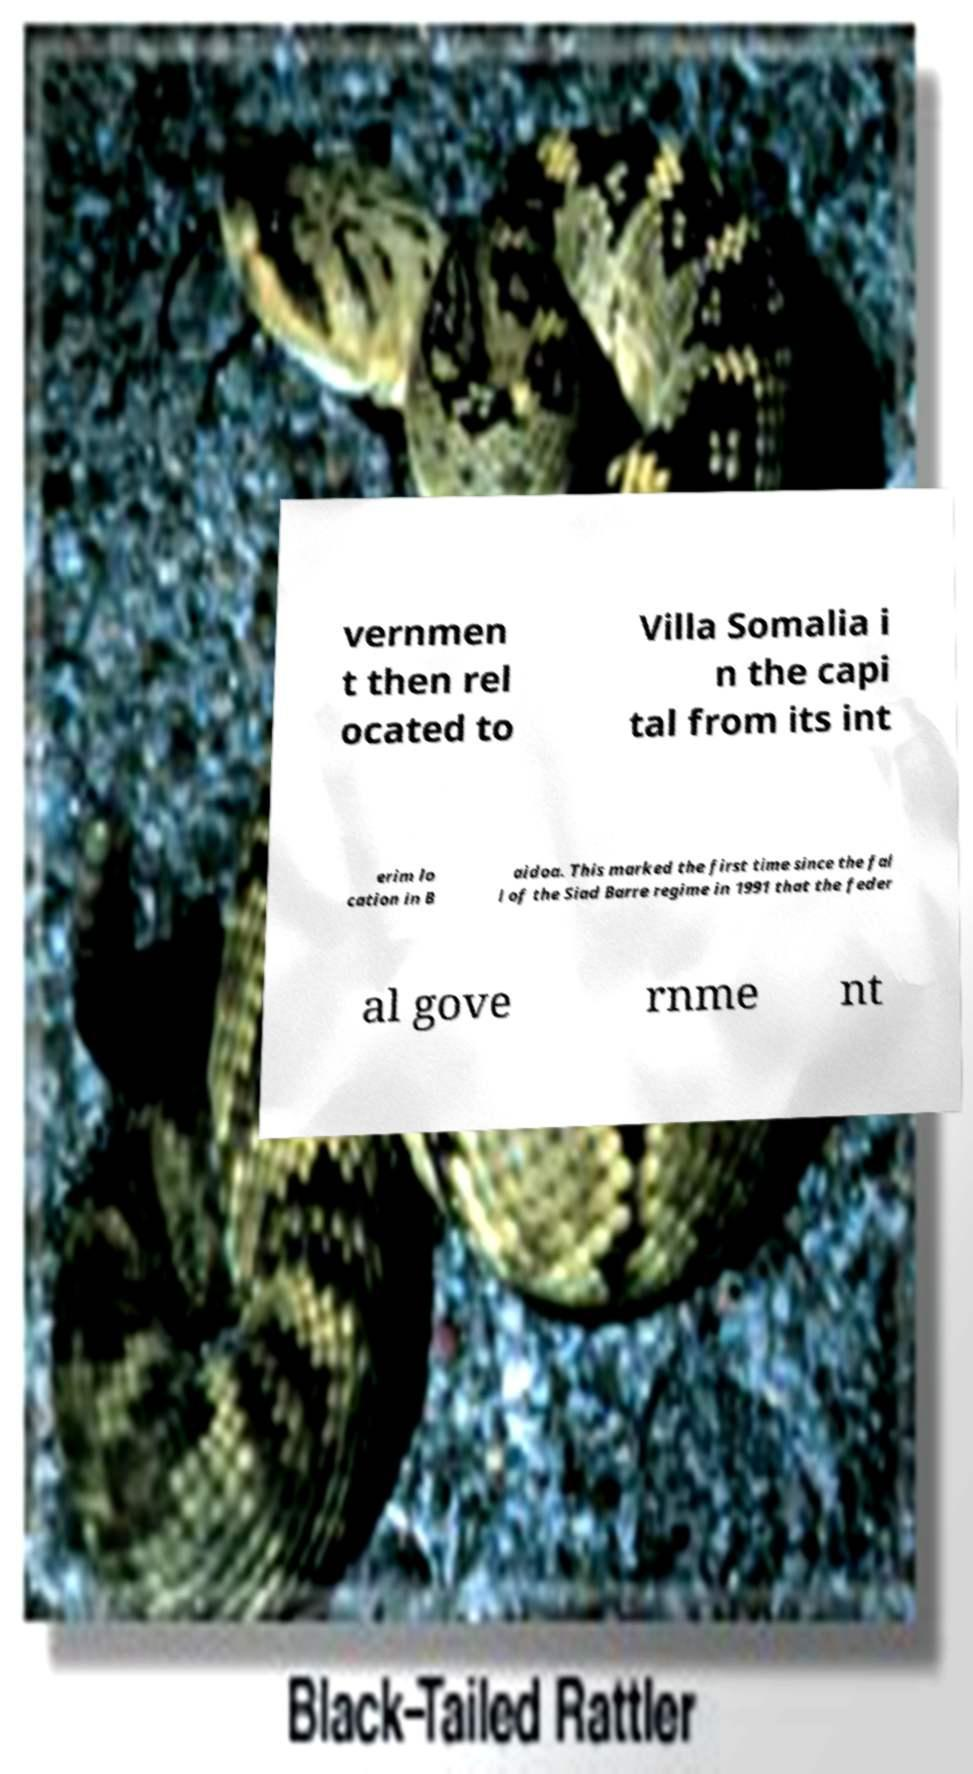Could you extract and type out the text from this image? vernmen t then rel ocated to Villa Somalia i n the capi tal from its int erim lo cation in B aidoa. This marked the first time since the fal l of the Siad Barre regime in 1991 that the feder al gove rnme nt 